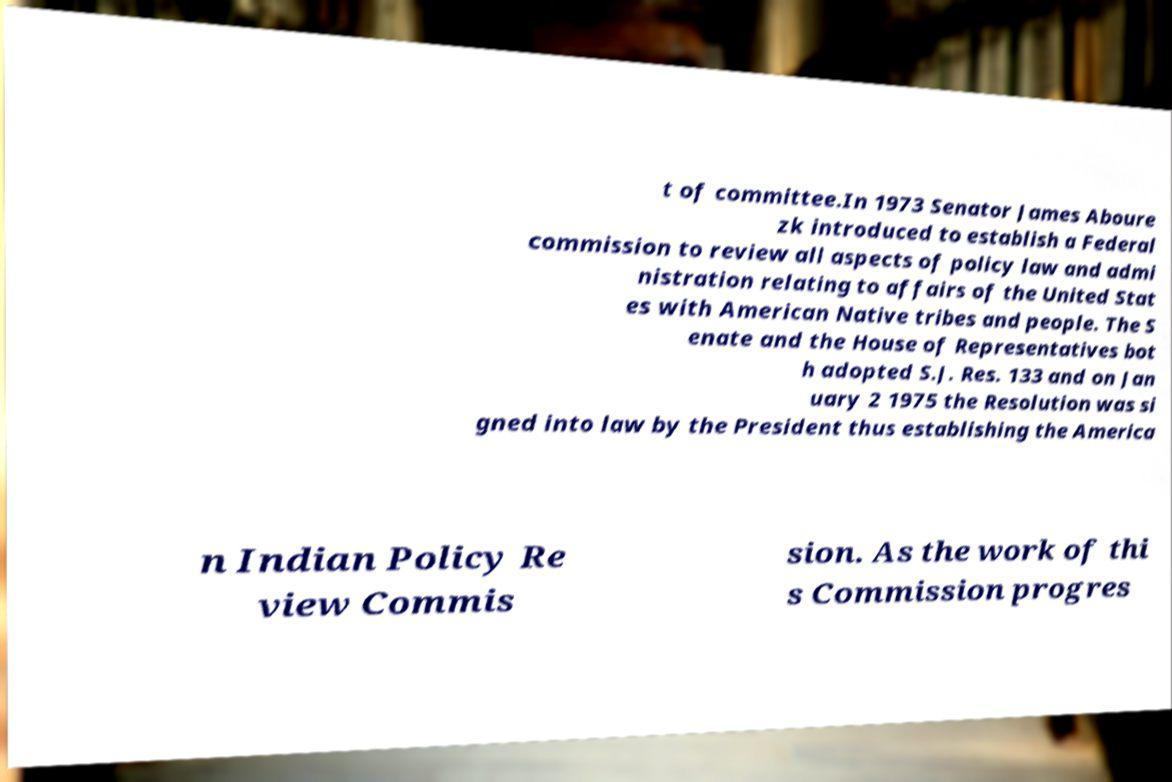For documentation purposes, I need the text within this image transcribed. Could you provide that? t of committee.In 1973 Senator James Aboure zk introduced to establish a Federal commission to review all aspects of policy law and admi nistration relating to affairs of the United Stat es with American Native tribes and people. The S enate and the House of Representatives bot h adopted S.J. Res. 133 and on Jan uary 2 1975 the Resolution was si gned into law by the President thus establishing the America n Indian Policy Re view Commis sion. As the work of thi s Commission progres 